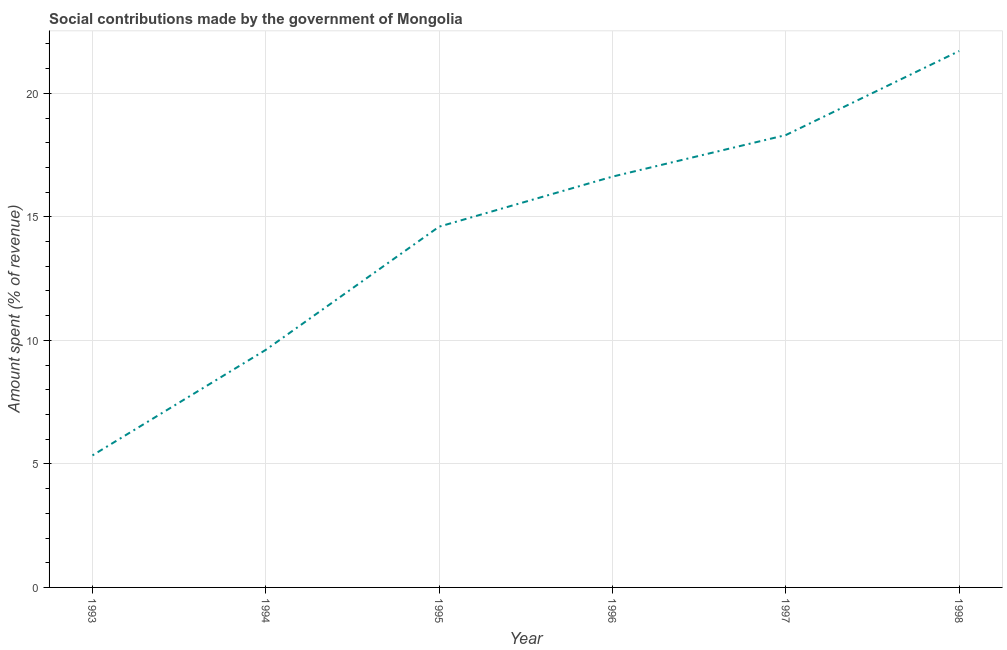What is the amount spent in making social contributions in 1998?
Provide a short and direct response. 21.71. Across all years, what is the maximum amount spent in making social contributions?
Offer a very short reply. 21.71. Across all years, what is the minimum amount spent in making social contributions?
Make the answer very short. 5.34. In which year was the amount spent in making social contributions maximum?
Your answer should be compact. 1998. In which year was the amount spent in making social contributions minimum?
Keep it short and to the point. 1993. What is the sum of the amount spent in making social contributions?
Offer a terse response. 86.21. What is the difference between the amount spent in making social contributions in 1994 and 1995?
Your answer should be compact. -4.99. What is the average amount spent in making social contributions per year?
Your answer should be compact. 14.37. What is the median amount spent in making social contributions?
Your answer should be very brief. 15.62. In how many years, is the amount spent in making social contributions greater than 17 %?
Ensure brevity in your answer.  2. Do a majority of the years between 1996 and 1997 (inclusive) have amount spent in making social contributions greater than 17 %?
Your response must be concise. No. What is the ratio of the amount spent in making social contributions in 1994 to that in 1997?
Ensure brevity in your answer.  0.53. Is the amount spent in making social contributions in 1994 less than that in 1996?
Make the answer very short. Yes. Is the difference between the amount spent in making social contributions in 1995 and 1998 greater than the difference between any two years?
Your answer should be very brief. No. What is the difference between the highest and the second highest amount spent in making social contributions?
Give a very brief answer. 3.4. Is the sum of the amount spent in making social contributions in 1993 and 1995 greater than the maximum amount spent in making social contributions across all years?
Your response must be concise. No. What is the difference between the highest and the lowest amount spent in making social contributions?
Make the answer very short. 16.37. In how many years, is the amount spent in making social contributions greater than the average amount spent in making social contributions taken over all years?
Your response must be concise. 4. Does the amount spent in making social contributions monotonically increase over the years?
Your response must be concise. Yes. How many years are there in the graph?
Keep it short and to the point. 6. Are the values on the major ticks of Y-axis written in scientific E-notation?
Your response must be concise. No. Does the graph contain grids?
Make the answer very short. Yes. What is the title of the graph?
Offer a terse response. Social contributions made by the government of Mongolia. What is the label or title of the X-axis?
Offer a terse response. Year. What is the label or title of the Y-axis?
Offer a very short reply. Amount spent (% of revenue). What is the Amount spent (% of revenue) of 1993?
Provide a short and direct response. 5.34. What is the Amount spent (% of revenue) of 1994?
Give a very brief answer. 9.62. What is the Amount spent (% of revenue) of 1995?
Make the answer very short. 14.6. What is the Amount spent (% of revenue) of 1996?
Your answer should be compact. 16.63. What is the Amount spent (% of revenue) in 1997?
Your answer should be very brief. 18.31. What is the Amount spent (% of revenue) of 1998?
Offer a very short reply. 21.71. What is the difference between the Amount spent (% of revenue) in 1993 and 1994?
Ensure brevity in your answer.  -4.27. What is the difference between the Amount spent (% of revenue) in 1993 and 1995?
Provide a short and direct response. -9.26. What is the difference between the Amount spent (% of revenue) in 1993 and 1996?
Offer a very short reply. -11.28. What is the difference between the Amount spent (% of revenue) in 1993 and 1997?
Offer a terse response. -12.97. What is the difference between the Amount spent (% of revenue) in 1993 and 1998?
Offer a terse response. -16.37. What is the difference between the Amount spent (% of revenue) in 1994 and 1995?
Ensure brevity in your answer.  -4.99. What is the difference between the Amount spent (% of revenue) in 1994 and 1996?
Your answer should be very brief. -7.01. What is the difference between the Amount spent (% of revenue) in 1994 and 1997?
Your response must be concise. -8.69. What is the difference between the Amount spent (% of revenue) in 1994 and 1998?
Provide a short and direct response. -12.09. What is the difference between the Amount spent (% of revenue) in 1995 and 1996?
Keep it short and to the point. -2.03. What is the difference between the Amount spent (% of revenue) in 1995 and 1997?
Provide a succinct answer. -3.71. What is the difference between the Amount spent (% of revenue) in 1995 and 1998?
Provide a succinct answer. -7.11. What is the difference between the Amount spent (% of revenue) in 1996 and 1997?
Give a very brief answer. -1.68. What is the difference between the Amount spent (% of revenue) in 1996 and 1998?
Your response must be concise. -5.08. What is the difference between the Amount spent (% of revenue) in 1997 and 1998?
Your answer should be compact. -3.4. What is the ratio of the Amount spent (% of revenue) in 1993 to that in 1994?
Give a very brief answer. 0.56. What is the ratio of the Amount spent (% of revenue) in 1993 to that in 1995?
Your answer should be compact. 0.37. What is the ratio of the Amount spent (% of revenue) in 1993 to that in 1996?
Offer a very short reply. 0.32. What is the ratio of the Amount spent (% of revenue) in 1993 to that in 1997?
Your answer should be compact. 0.29. What is the ratio of the Amount spent (% of revenue) in 1993 to that in 1998?
Keep it short and to the point. 0.25. What is the ratio of the Amount spent (% of revenue) in 1994 to that in 1995?
Ensure brevity in your answer.  0.66. What is the ratio of the Amount spent (% of revenue) in 1994 to that in 1996?
Provide a succinct answer. 0.58. What is the ratio of the Amount spent (% of revenue) in 1994 to that in 1997?
Ensure brevity in your answer.  0.53. What is the ratio of the Amount spent (% of revenue) in 1994 to that in 1998?
Provide a short and direct response. 0.44. What is the ratio of the Amount spent (% of revenue) in 1995 to that in 1996?
Give a very brief answer. 0.88. What is the ratio of the Amount spent (% of revenue) in 1995 to that in 1997?
Give a very brief answer. 0.8. What is the ratio of the Amount spent (% of revenue) in 1995 to that in 1998?
Ensure brevity in your answer.  0.67. What is the ratio of the Amount spent (% of revenue) in 1996 to that in 1997?
Ensure brevity in your answer.  0.91. What is the ratio of the Amount spent (% of revenue) in 1996 to that in 1998?
Offer a very short reply. 0.77. What is the ratio of the Amount spent (% of revenue) in 1997 to that in 1998?
Your answer should be compact. 0.84. 